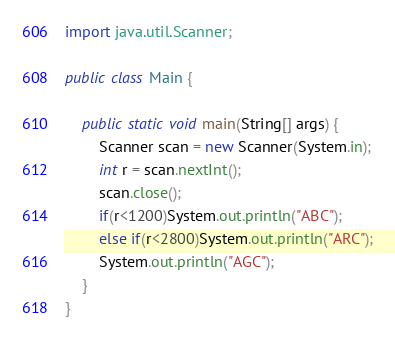Convert code to text. <code><loc_0><loc_0><loc_500><loc_500><_Java_>import java.util.Scanner;

public class Main {

	public static void main(String[] args) {
		Scanner scan = new Scanner(System.in);
		int r = scan.nextInt();
		scan.close();
		if(r<1200)System.out.println("ABC");
		else if(r<2800)System.out.println("ARC");
		System.out.println("AGC");
	}
}</code> 